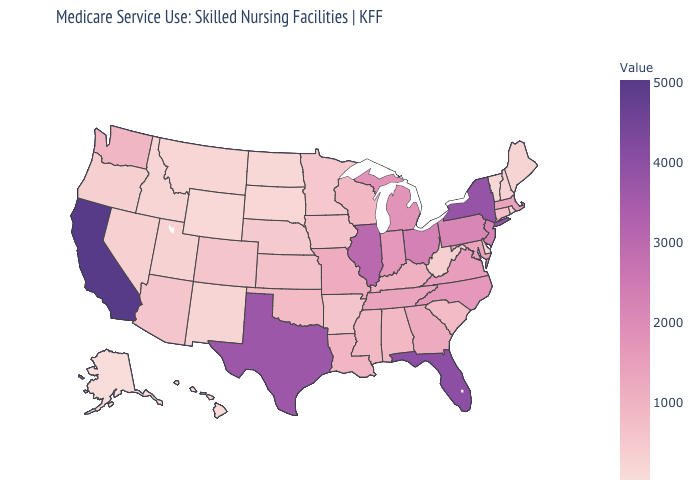Among the states that border New Mexico , which have the lowest value?
Concise answer only. Utah. Among the states that border New Mexico , which have the highest value?
Give a very brief answer. Texas. Is the legend a continuous bar?
Concise answer only. Yes. Does Wisconsin have the highest value in the USA?
Short answer required. No. Which states have the highest value in the USA?
Short answer required. California. Which states have the highest value in the USA?
Write a very short answer. California. Which states have the highest value in the USA?
Short answer required. California. 